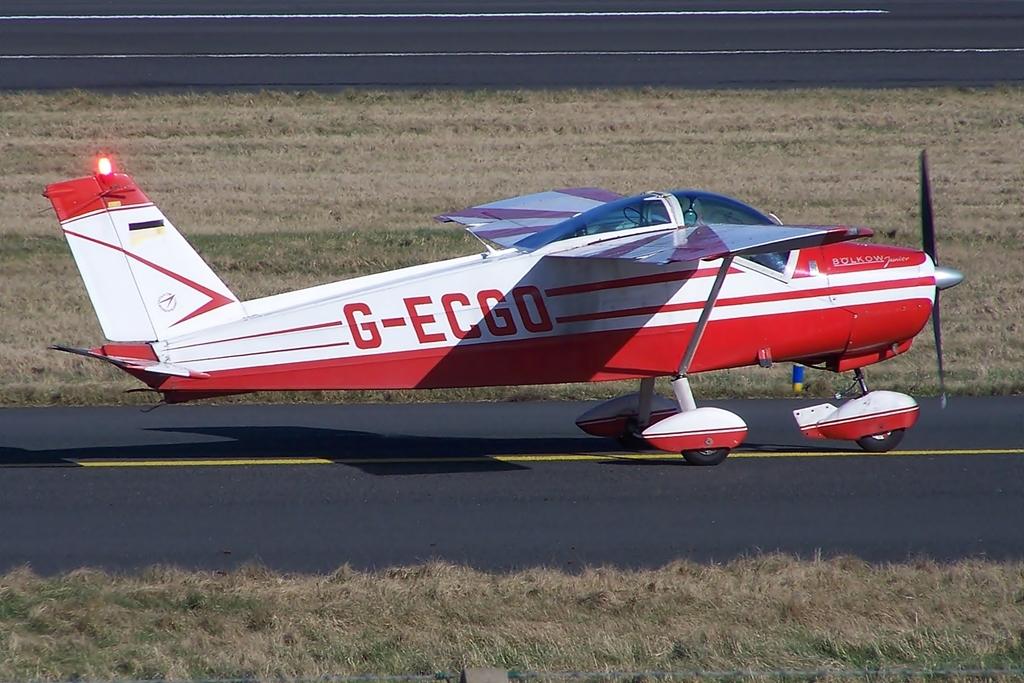What are the five letters on the side of the plane?
Give a very brief answer. G-ecgo. What type of plane is that?
Keep it short and to the point. Bolkow. 